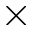Convert formula to latex. <formula><loc_0><loc_0><loc_500><loc_500>\times</formula> 